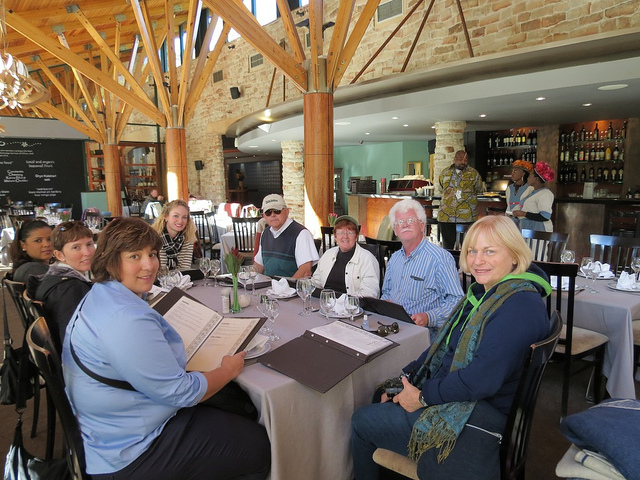Describe the attire of the people in the photo. The individuals in the photo are dressed in casual wear, with some wearing light jackets and sweaters, suggesting a casual dining atmosphere, perhaps during the day or in a location with a mild climate. 